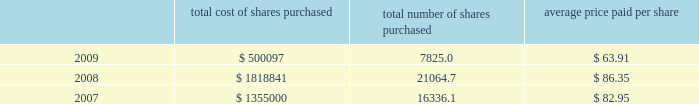Part ii , item 7 until maturity , effectively making this a us dollar denominated debt on which schlumberger will pay interest in us dollars at a rate of 4.74% ( 4.74 % ) .
The proceeds from these notes were used to repay commercial paper borrowings .
0160 on april 20 , 2006 , the schlumberger board of directors approved a share repurchase program of up to 40 million shares of common stock to be acquired in the open market before april 2010 , subject to market conditions .
This program was completed during the second quarter of 2008 .
On april 17 , 2008 , the schlumberger board of directors approved an $ 8 billion share repurchase program for shares of schlumberger common stock , to be acquired in the open market before december 31 , 2011 , of which $ 1.43 billion had been repurchased as of december 31 , 2009 .
The table summarizes the activity under these share repurchase programs during 2009 , 2008 and ( stated in thousands except per share amounts and prices ) total cost of shares purchased total number of shares purchased average price paid per share .
0160 cash flow provided by operations was $ 5.3 billion in 2009 , $ 6.9 billion in 2008 and $ 6.3 billion in 2007 .
The decline in cash flow from operations in 2009 as compared to 2008 was primarily driven by the decrease in net income experienced in 2009 and the significant pension plan contributions made during 2009 , offset by an improvement in working capital requirements .
The improvement in 2008 as compared to 2007 was driven by the net income increase experienced in 2008 offset by required investments in working capital .
The reduction in cash flows experienced by some of schlumberger 2019s customers as a result of global economic conditions could have significant adverse effects on their financial condition .
This could result in , among other things , delay in , or nonpayment of , amounts that are owed to schlumberger , which could have a material adverse effect on schlumberger 2019s results of operations and cash flows .
At times in recent quarters , schlumberger has experienced delays in payments from certain of its customers .
Schlumberger operates in approximately 80 countries .
At december 31 , 2009 , only three of those countries individually accounted for greater than 5% ( 5 % ) of schlumberger 2019s accounts receivable balance of which only one represented greater than 0160 during 2008 and 2007 , schlumberger announced that its board of directors had approved increases in the quarterly dividend of 20% ( 20 % ) and 40% ( 40 % ) , respectively .
Total dividends paid during 2009 , 2008 and 2007 were $ 1.0 billion , $ 964 million and $ 771 million , respectively .
0160 capital expenditures were $ 2.4 billion in 2009 , $ 3.7 billion in 2008 and $ 2.9 billion in 2007 .
Capital expenditures in 2008 and 2007 reflected the record activity levels experienced in those years .
The decrease in capital expenditures in 2009 as compared to 2008 is primarily due to the significant activity decline during 2009 .
Oilfield services capital expenditures are expected to approach $ 2.4 billion for the full year 2010 as compared to $ 1.9 billion in 2009 and $ 3.0 billion in 2008 .
Westerngeco capital expenditures are expected to approach $ 0.3 billion for the full year 2010 as compared to $ 0.5 billion in 2009 and $ 0.7 billion in 2008. .
What is the ratio of the total costs of shares purchased from 2008 to 2009 in dollars? 
Rationale: the company spent 3.6 times on shares in 2008 compared to 2009
Computations: (1818841 / 500097)
Answer: 3.63698. 